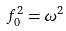Convert formula to latex. <formula><loc_0><loc_0><loc_500><loc_500>f _ { 0 } ^ { 2 } = \omega ^ { 2 }</formula> 